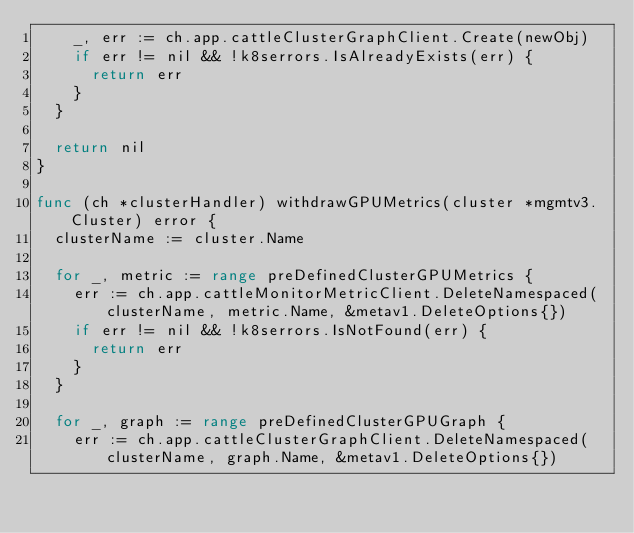Convert code to text. <code><loc_0><loc_0><loc_500><loc_500><_Go_>		_, err := ch.app.cattleClusterGraphClient.Create(newObj)
		if err != nil && !k8serrors.IsAlreadyExists(err) {
			return err
		}
	}

	return nil
}

func (ch *clusterHandler) withdrawGPUMetrics(cluster *mgmtv3.Cluster) error {
	clusterName := cluster.Name

	for _, metric := range preDefinedClusterGPUMetrics {
		err := ch.app.cattleMonitorMetricClient.DeleteNamespaced(clusterName, metric.Name, &metav1.DeleteOptions{})
		if err != nil && !k8serrors.IsNotFound(err) {
			return err
		}
	}

	for _, graph := range preDefinedClusterGPUGraph {
		err := ch.app.cattleClusterGraphClient.DeleteNamespaced(clusterName, graph.Name, &metav1.DeleteOptions{})</code> 